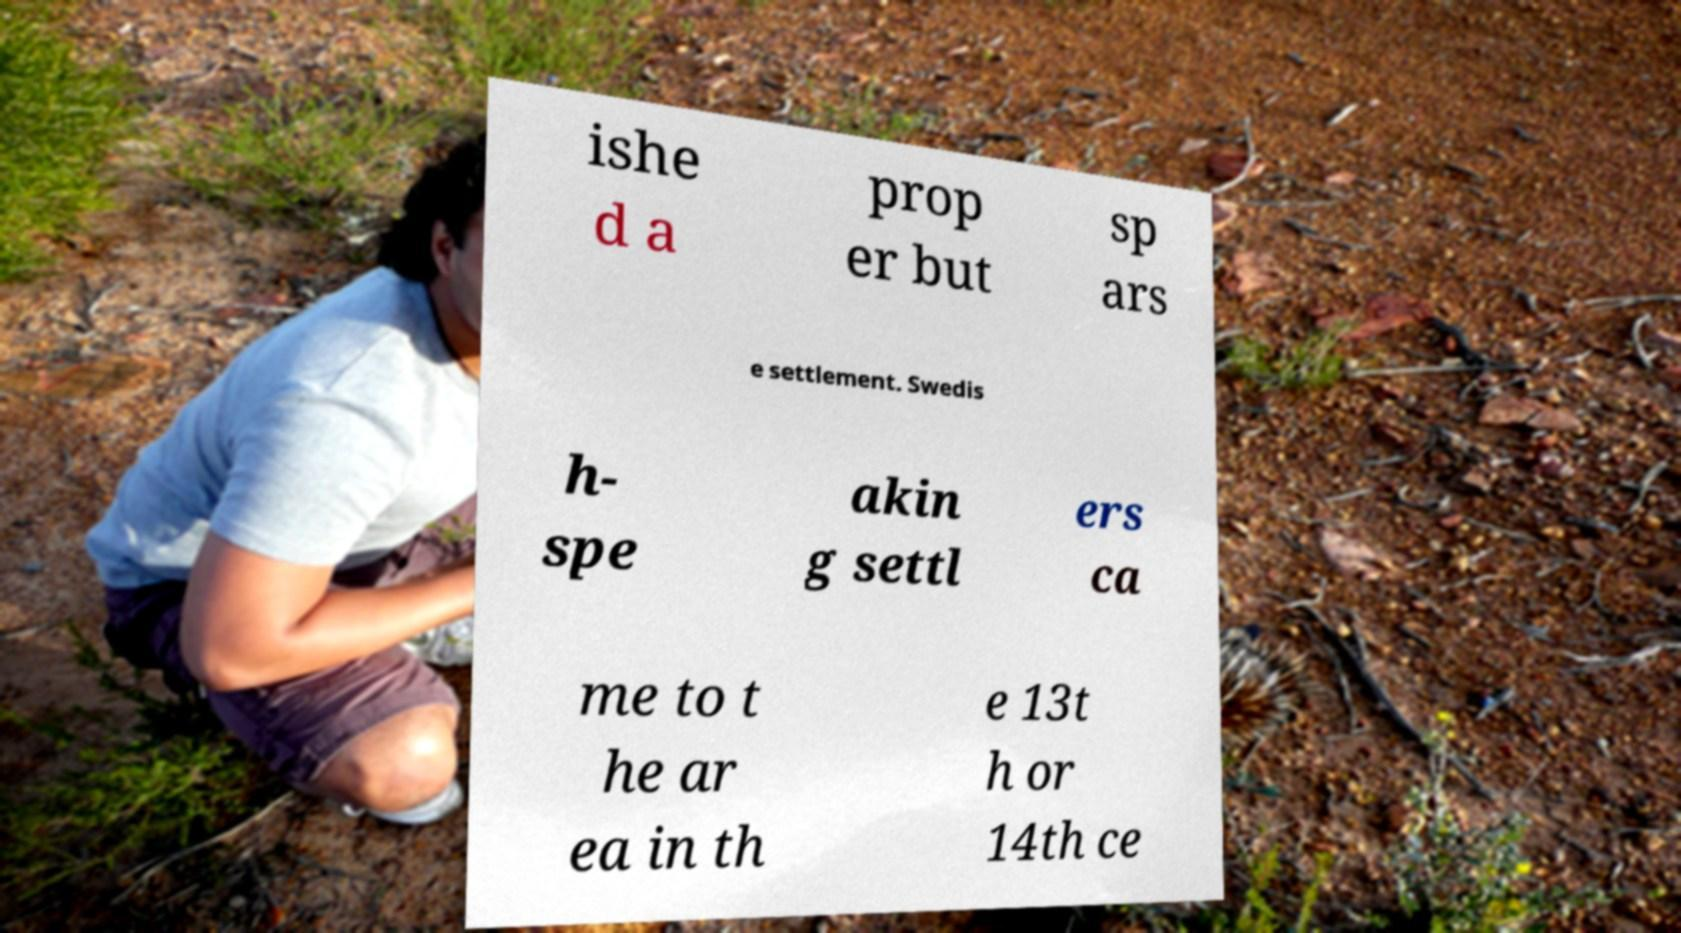Please identify and transcribe the text found in this image. ishe d a prop er but sp ars e settlement. Swedis h- spe akin g settl ers ca me to t he ar ea in th e 13t h or 14th ce 